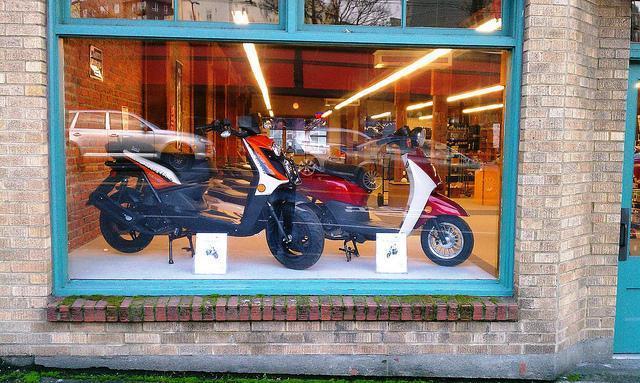How many people can ride this vehicle?
Give a very brief answer. 2. How many cars are there?
Give a very brief answer. 2. How many motorcycles are there?
Give a very brief answer. 2. 